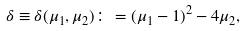Convert formula to latex. <formula><loc_0><loc_0><loc_500><loc_500>\delta \equiv \delta ( \mu _ { 1 } , \mu _ { 2 } ) \colon = ( \mu _ { 1 } - 1 ) ^ { 2 } - 4 \mu _ { 2 } ,</formula> 